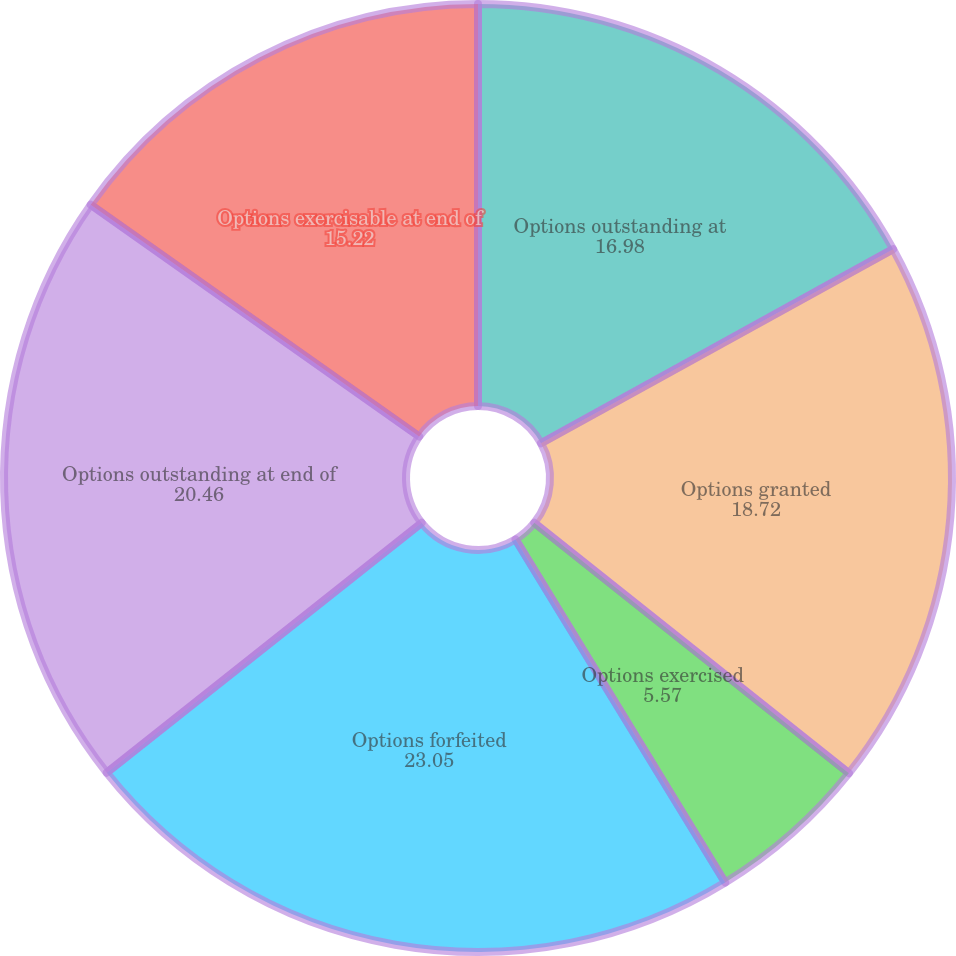Convert chart. <chart><loc_0><loc_0><loc_500><loc_500><pie_chart><fcel>Options outstanding at<fcel>Options granted<fcel>Options exercised<fcel>Options forfeited<fcel>Options outstanding at end of<fcel>Options exercisable at end of<nl><fcel>16.98%<fcel>18.72%<fcel>5.57%<fcel>23.05%<fcel>20.46%<fcel>15.22%<nl></chart> 